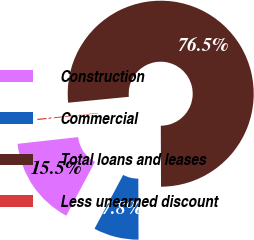Convert chart to OTSL. <chart><loc_0><loc_0><loc_500><loc_500><pie_chart><fcel>Construction<fcel>Commercial<fcel>Total loans and leases<fcel>Less unearned discount<nl><fcel>15.46%<fcel>7.84%<fcel>76.49%<fcel>0.21%<nl></chart> 